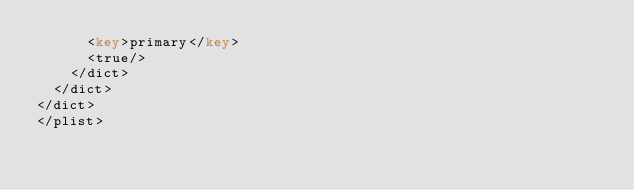<code> <loc_0><loc_0><loc_500><loc_500><_XML_>			<key>primary</key>
			<true/>
		</dict>
	</dict>
</dict>
</plist>
</code> 